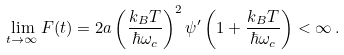<formula> <loc_0><loc_0><loc_500><loc_500>\lim _ { t \rightarrow \infty } F ( t ) = 2 a \left ( \frac { k _ { B } T } { \hbar { \omega } _ { c } } \right ) ^ { 2 } \psi ^ { \prime } \left ( 1 + \frac { k _ { B } T } { \hbar { \omega } _ { c } } \right ) < \infty \, .</formula> 